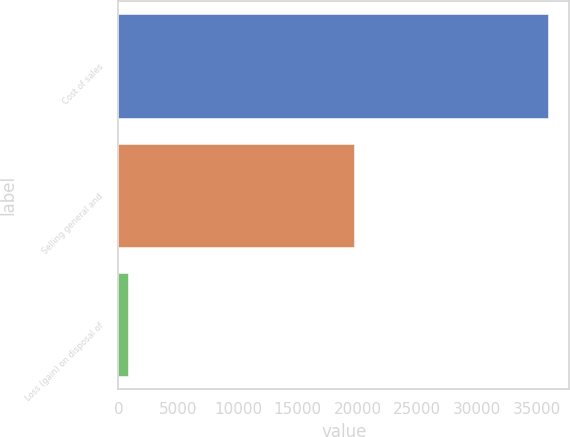Convert chart. <chart><loc_0><loc_0><loc_500><loc_500><bar_chart><fcel>Cost of sales<fcel>Selling general and<fcel>Loss (gain) on disposal of<nl><fcel>35932<fcel>19681<fcel>784<nl></chart> 